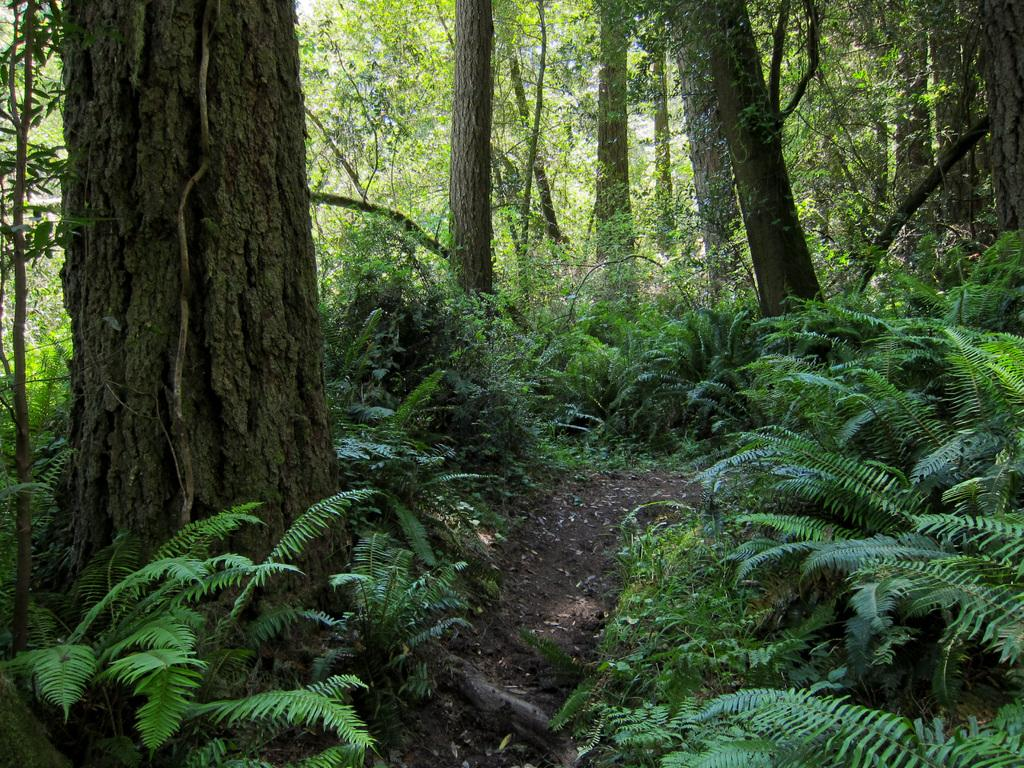What type of vegetation can be seen in the background of the image? There are plants and trees in the background of the image. Can you describe the natural environment visible in the image? The natural environment includes plants and trees in the background. What type of metal can be seen in the image? There is no metal present in the image; it features plants and trees in the background. Is there a tent visible in the image? There is no tent present in the image. 